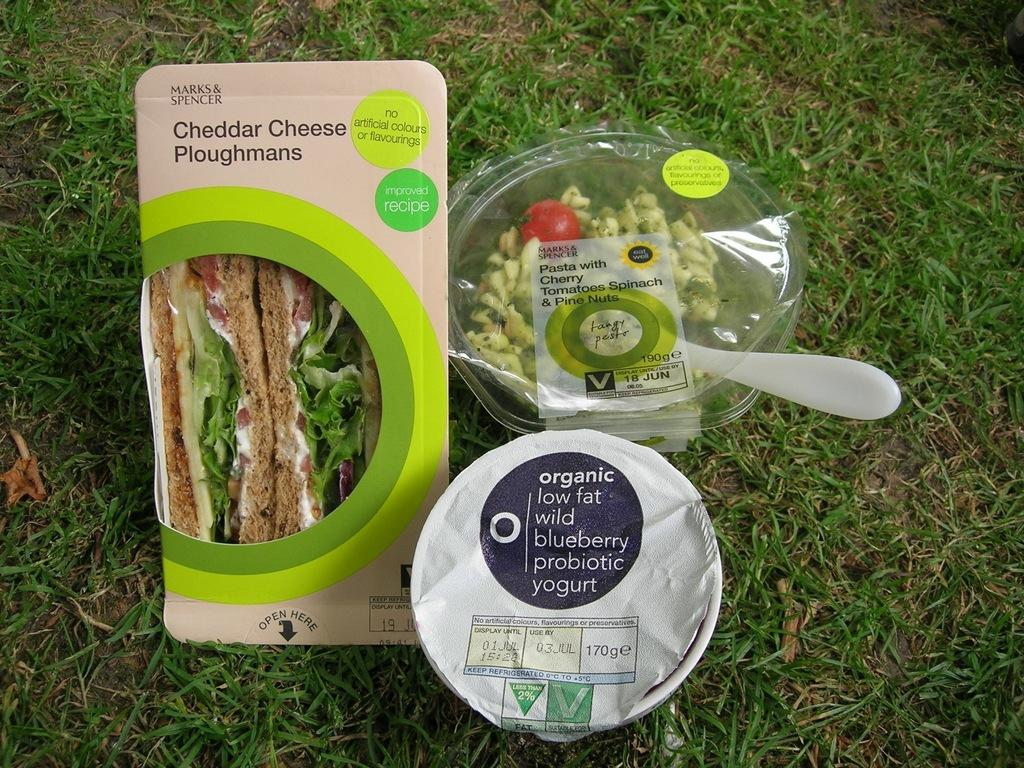What else is in the center of the image besides the sandwich? There is yogurt and a spoon in the center of the image. What type of utensil is used with the yogurt? A spoon is present in the center of the image. What can be seen in the background of the image? There is grass in the background of the image. How many cows are grazing on the grass in the background of the image? There are no cows present in the image; it only shows a sandwich, yogurt, a spoon, and grass in the background. What type of amusement park can be seen in the background of the image? There is no amusement park present in the image; it only shows a sandwich, yogurt, a spoon, and grass in the background. 